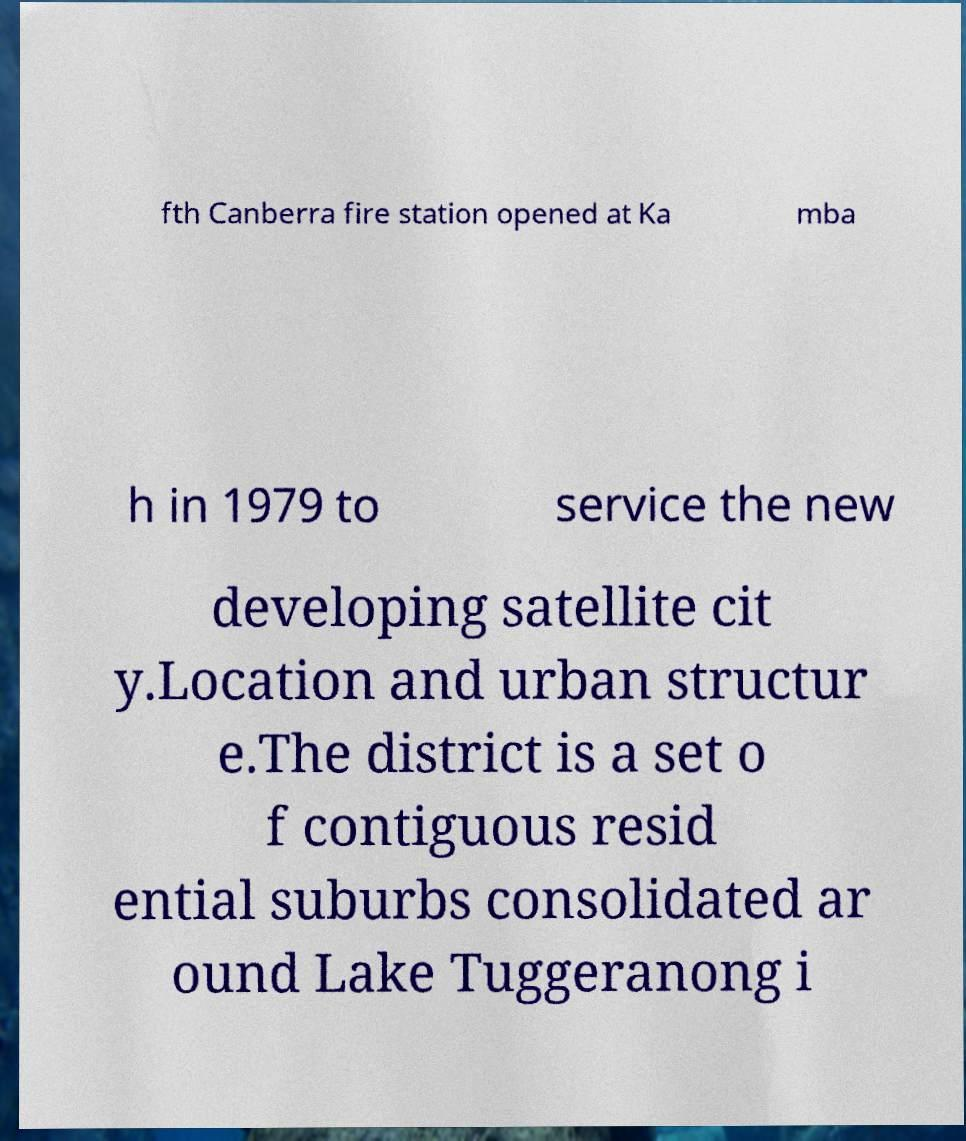Please identify and transcribe the text found in this image. fth Canberra fire station opened at Ka mba h in 1979 to service the new developing satellite cit y.Location and urban structur e.The district is a set o f contiguous resid ential suburbs consolidated ar ound Lake Tuggeranong i 